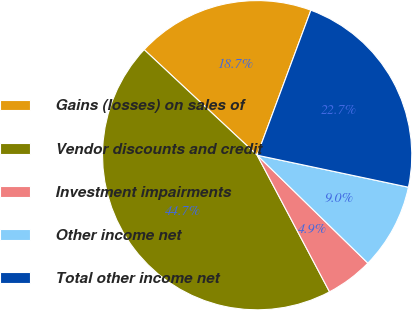<chart> <loc_0><loc_0><loc_500><loc_500><pie_chart><fcel>Gains (losses) on sales of<fcel>Vendor discounts and credit<fcel>Investment impairments<fcel>Other income net<fcel>Total other income net<nl><fcel>18.69%<fcel>44.71%<fcel>4.95%<fcel>8.98%<fcel>22.67%<nl></chart> 